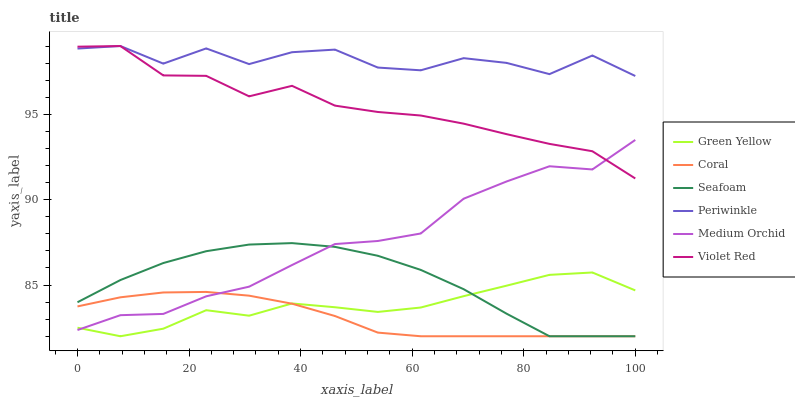Does Coral have the minimum area under the curve?
Answer yes or no. Yes. Does Periwinkle have the maximum area under the curve?
Answer yes or no. Yes. Does Medium Orchid have the minimum area under the curve?
Answer yes or no. No. Does Medium Orchid have the maximum area under the curve?
Answer yes or no. No. Is Coral the smoothest?
Answer yes or no. Yes. Is Periwinkle the roughest?
Answer yes or no. Yes. Is Medium Orchid the smoothest?
Answer yes or no. No. Is Medium Orchid the roughest?
Answer yes or no. No. Does Coral have the lowest value?
Answer yes or no. Yes. Does Medium Orchid have the lowest value?
Answer yes or no. No. Does Periwinkle have the highest value?
Answer yes or no. Yes. Does Medium Orchid have the highest value?
Answer yes or no. No. Is Green Yellow less than Periwinkle?
Answer yes or no. Yes. Is Periwinkle greater than Green Yellow?
Answer yes or no. Yes. Does Coral intersect Seafoam?
Answer yes or no. Yes. Is Coral less than Seafoam?
Answer yes or no. No. Is Coral greater than Seafoam?
Answer yes or no. No. Does Green Yellow intersect Periwinkle?
Answer yes or no. No. 